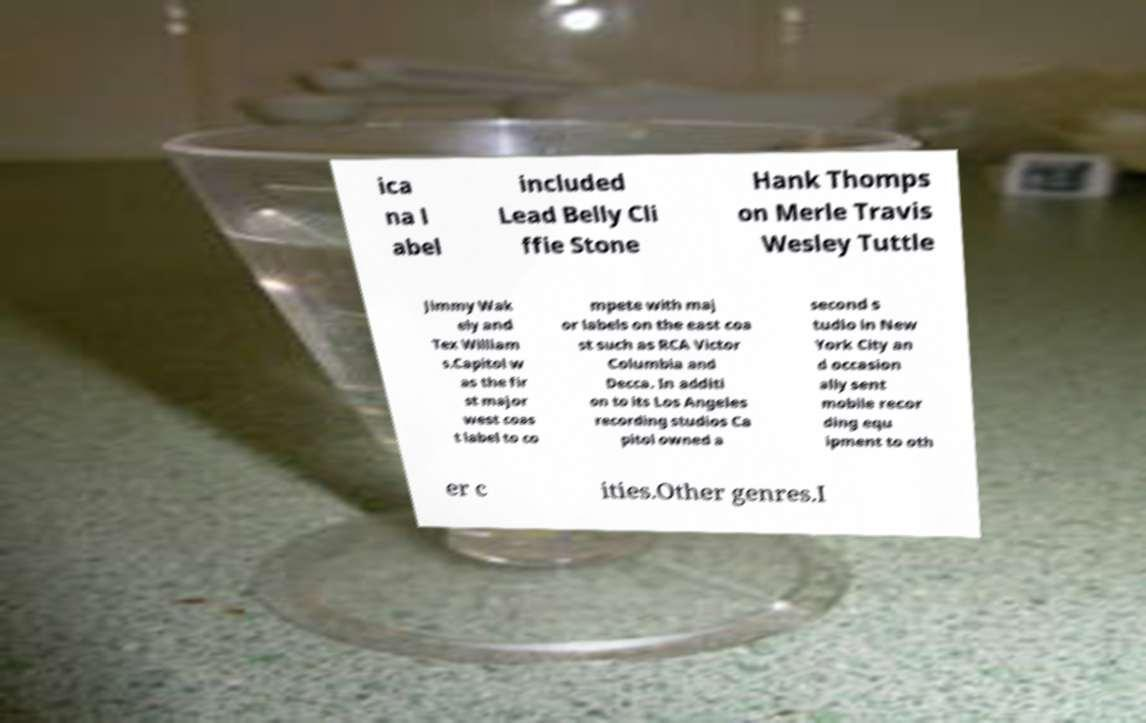Can you read and provide the text displayed in the image?This photo seems to have some interesting text. Can you extract and type it out for me? ica na l abel included Lead Belly Cli ffie Stone Hank Thomps on Merle Travis Wesley Tuttle Jimmy Wak ely and Tex William s.Capitol w as the fir st major west coas t label to co mpete with maj or labels on the east coa st such as RCA Victor Columbia and Decca. In additi on to its Los Angeles recording studios Ca pitol owned a second s tudio in New York City an d occasion ally sent mobile recor ding equ ipment to oth er c ities.Other genres.I 